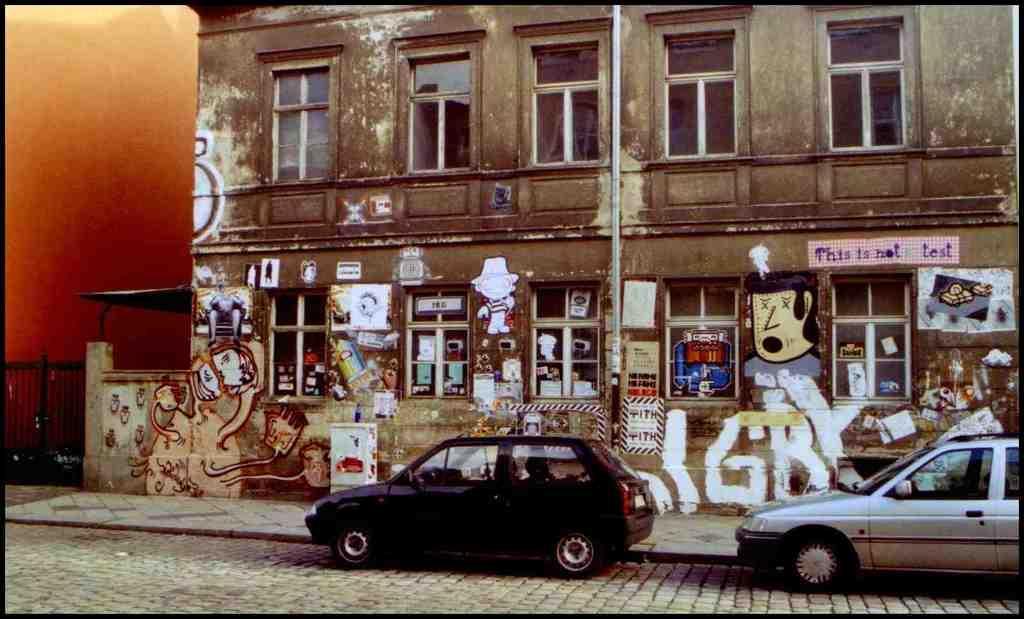In one or two sentences, can you explain what this image depicts? In this image we can see a building and it is having few windows. There are few vehicles in the image. There is some text and few paintings on the wall. There is a gate at the left side of the image. 